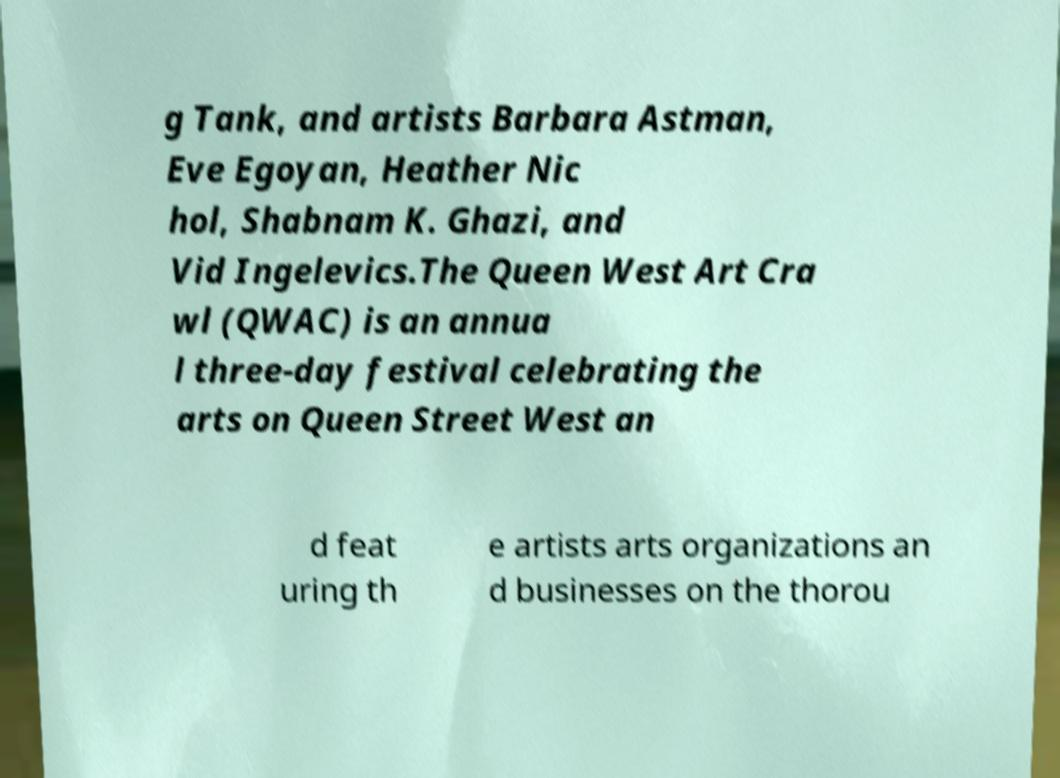I need the written content from this picture converted into text. Can you do that? g Tank, and artists Barbara Astman, Eve Egoyan, Heather Nic hol, Shabnam K. Ghazi, and Vid Ingelevics.The Queen West Art Cra wl (QWAC) is an annua l three-day festival celebrating the arts on Queen Street West an d feat uring th e artists arts organizations an d businesses on the thorou 